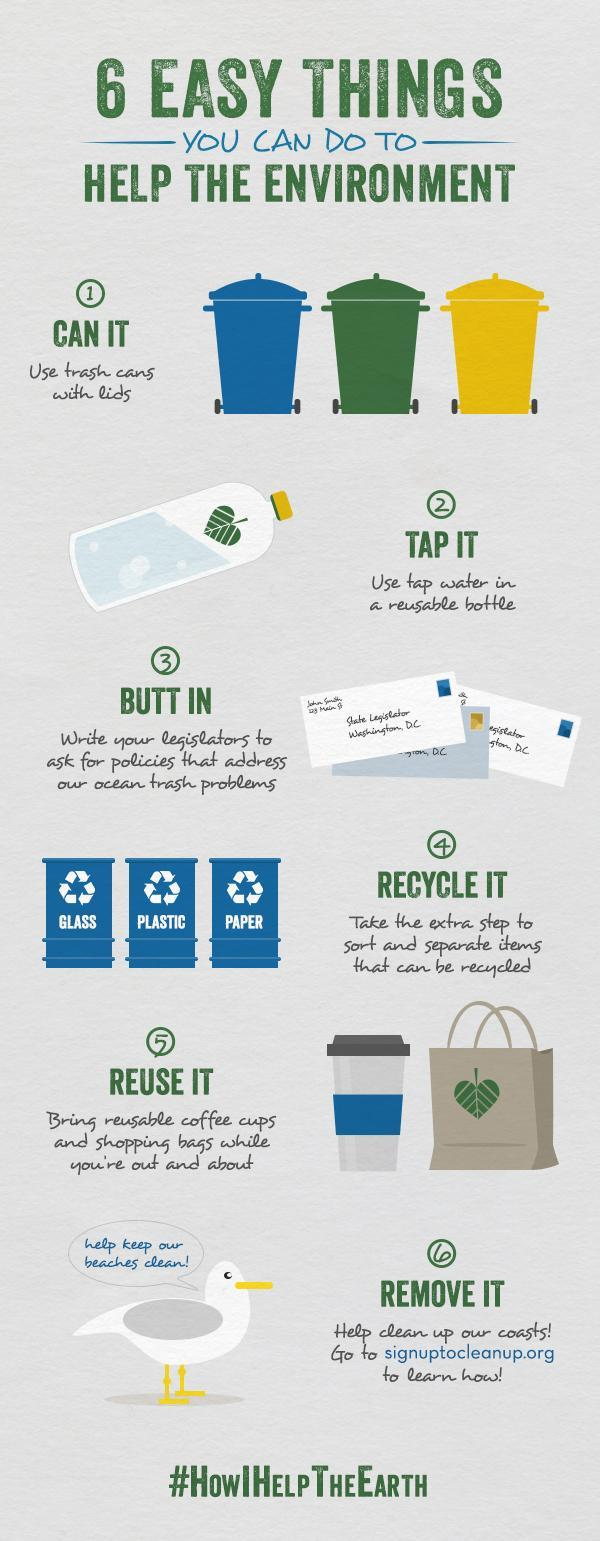How many trash cans are in this infographic?
Answer the question with a short phrase. 3 How many coffee cups are in this infographic? 1 